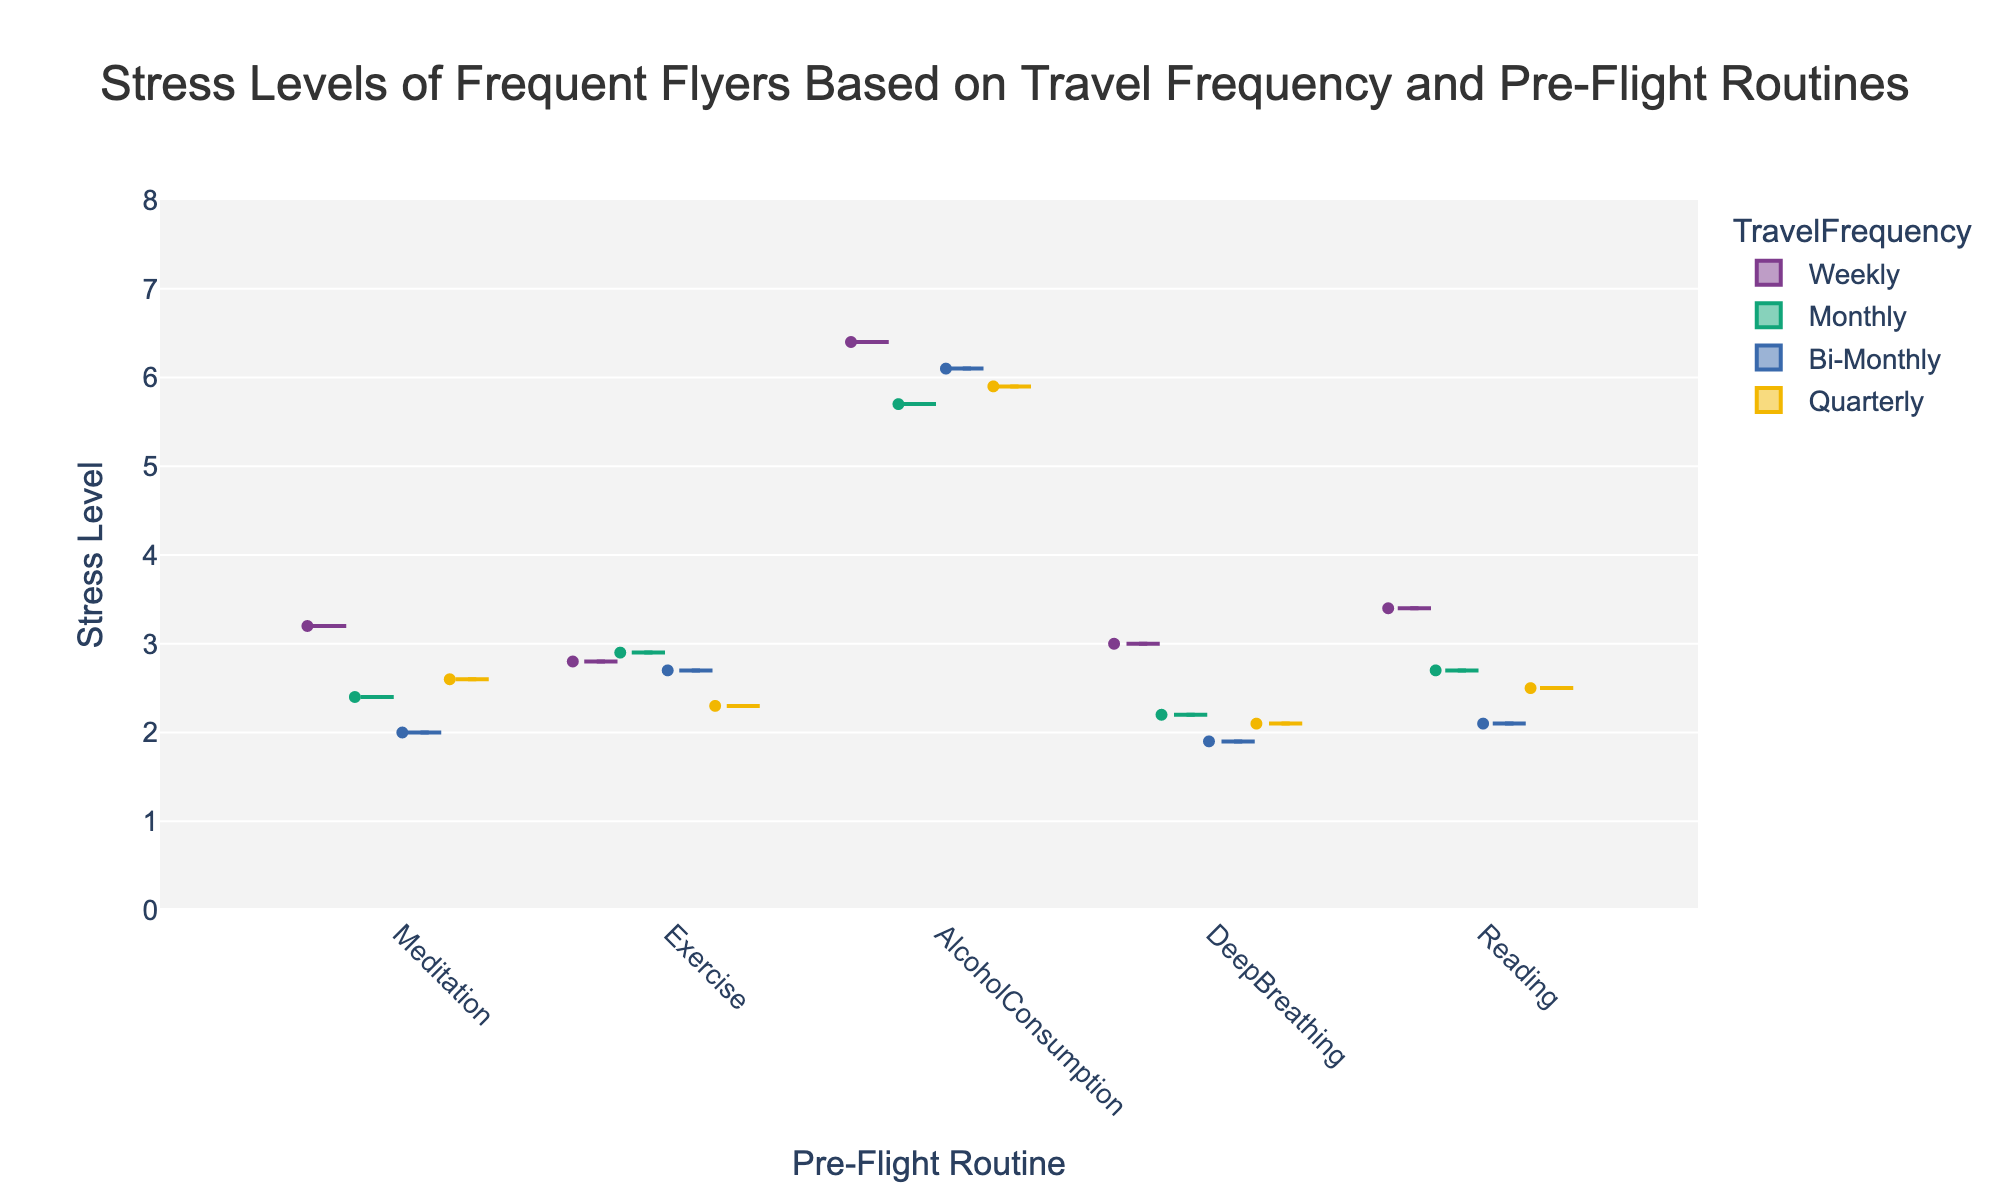what is the title of the figure? The title of the figure is usually displayed at the top and provides a brief summary of what the chart represents.
Answer: Stress Levels of Frequent Flyers Based on Travel Frequency and Pre-Flight Routines how many pre-flight routines are represented? There are distinct categories on the x-axis for each pre-flight routine, showing how travelers' stress levels are distributed across them.
Answer: Five which travel frequency has the highest stress level in the alcohol consumption group? By looking at the color of the violin plots in the "AlcoholConsumption" group, we can identify which one extends the furthest up the y-axis.
Answer: Weekly what is the median stress level for monthly travelers who meditate? The box plot within the violin plot marks the median with a line; find the corresponding value within the "Meditation" category and "Monthly" color.
Answer: 2.4 how does the interquartile range of stress levels differ between weekly and quarterly travelers who exercise? The interquartile range (IQR) is the part of the box plot between the 25th and 75th percentiles; by comparing these in the "Exercise" category for "Weekly" and "Quarterly" travelers, we examine the differences in IQR heights.
Answer: Weekly is longer than quarterly which pre-flight routine shows the lowest median stress level overall? By comparing the lines indicating the median in each violin plot, we can determine which is the lowest across all routines.
Answer: DeepBreathing which travel frequency group has the widest distribution of stress levels for the reading routine? The width and spread of the violin plot show the distribution; the one with the widest spread along the y-axis within the "Reading" category highlights the group.
Answer: Weekly compare the median stress levels for bi-monthly and quarterly travelers who consume alcohol. Look at the median lines in the box plots within the "AlcoholConsumption" category for both "Bi-Monthly" and "Quarterly" to determine the difference.
Answer: Bi-Monthly is higher than Quarterly 